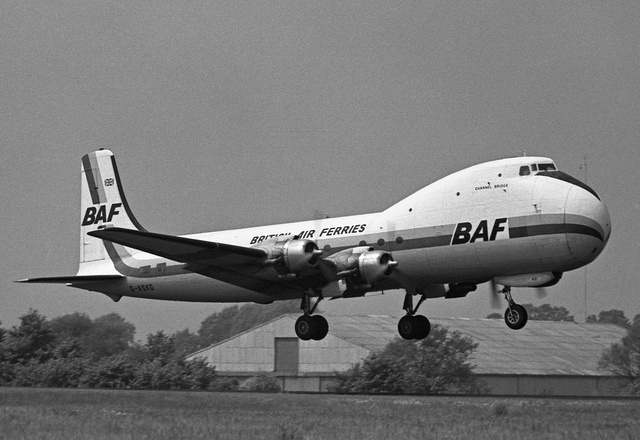Describe the objects in this image and their specific colors. I can see a airplane in gray, black, lightgray, and darkgray tones in this image. 